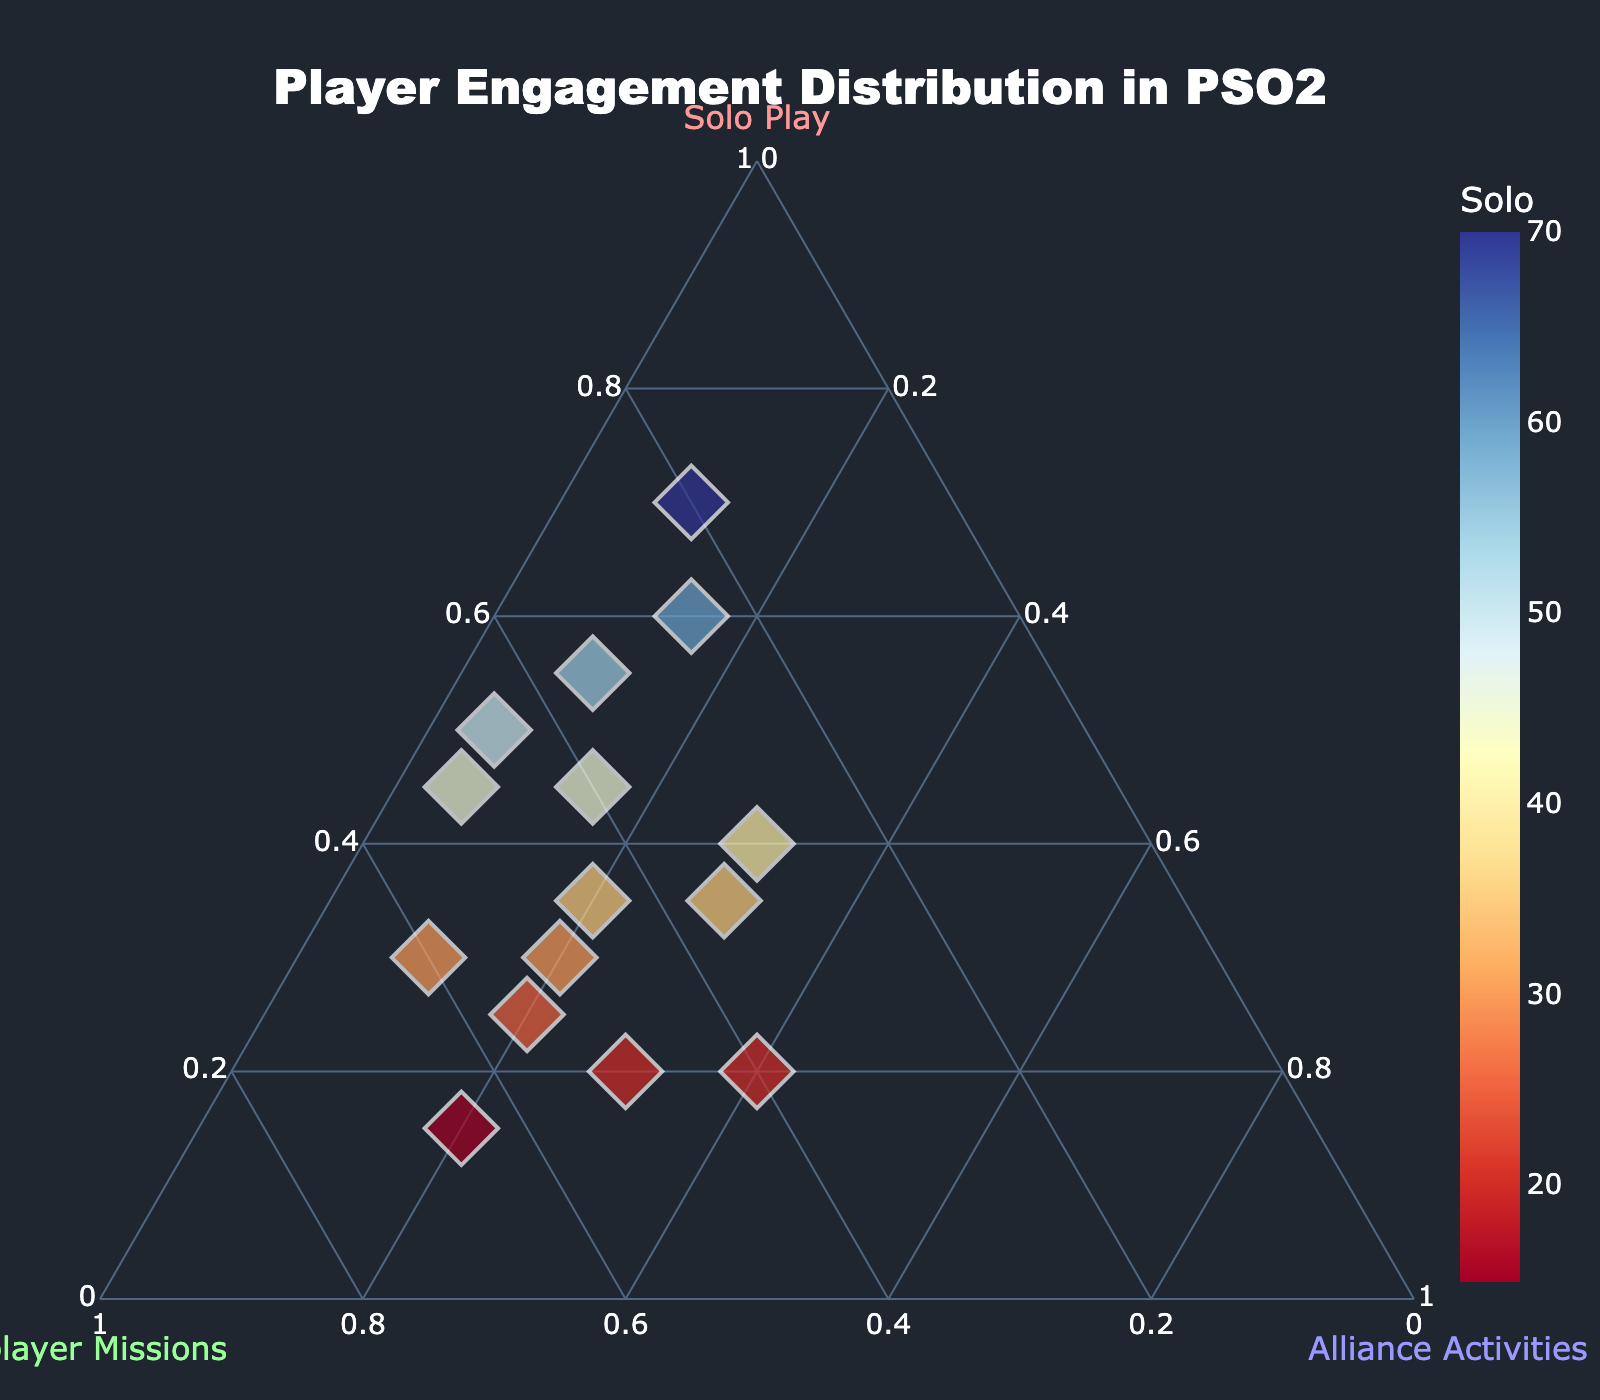How many data points are shown in the ternary plot? By counting the number of unique points plotted on the figure, you can determine that there are 15 data points.
Answer: 15 What does the axis labeled "Solo Play" represent in the ternary plot? The "Solo Play" axis shows the proportion of player engagement dedicated to solo activities, ranging from 0% to 100%.
Answer: Engagement in solo activities Which player has the highest percentage of "Multiplayer Missions" engagement? By observing the data points, the highest "Multiplayer Missions" engagement is 65%, which corresponds to the player engaging 15% in Solo Play and 20% in Alliance Activities.
Answer: The player with 15% Solo, 65% Multiplayer, and 20% Alliance Is there a player with an equal split of engagement between all three activities? Equal split means each activity should have about 33.33% engagement. There is no data point with exactly equal proportions in all activities.
Answer: No Which activity shows the most variation in player engagement? By looking at the spread of data points along each ternary axis, Multiplayer Missions show the widest range from 20% to 65%, indicating the most variation.
Answer: Multiplayer Missions What is the average "Alliance Activities" engagement across all players? Calculating the average of the Alliance Activities values: (15 + 10 + 30 + 10 + 20 + 20 + 30 + 5 + 20 + 15 + 30 + 5 + 40 + 10 + 20)/15 = 20.67
Answer: 20.67 How many players have more than 50% engagement in "Solo Play"? By counting the points where Solo Play engagement is greater than 50%, there are three such players.
Answer: 3 Compare the player with with highest solo engagement to the one with highest multiplayer engagement. Which one spends more time on alliance activities? The highest Solo Play engagement is 70% with 10% Alliance Activities. The highest Multiplayer Missions engagement is 65% with 20% Alliance Activities. Therefore, the latter spends more time on Alliance activities.
Answer: The player with highest Multiplayer Missions engagement What group combination has the most players? By observing the distribution of points, the clustering around 30-50% Solo Play and 50-60% Multiplayer Missions with 10-20% Alliance Activities is the densest.
Answer: 30-50% Solo, 50-60% Multiplayer, 10-20% Alliance 